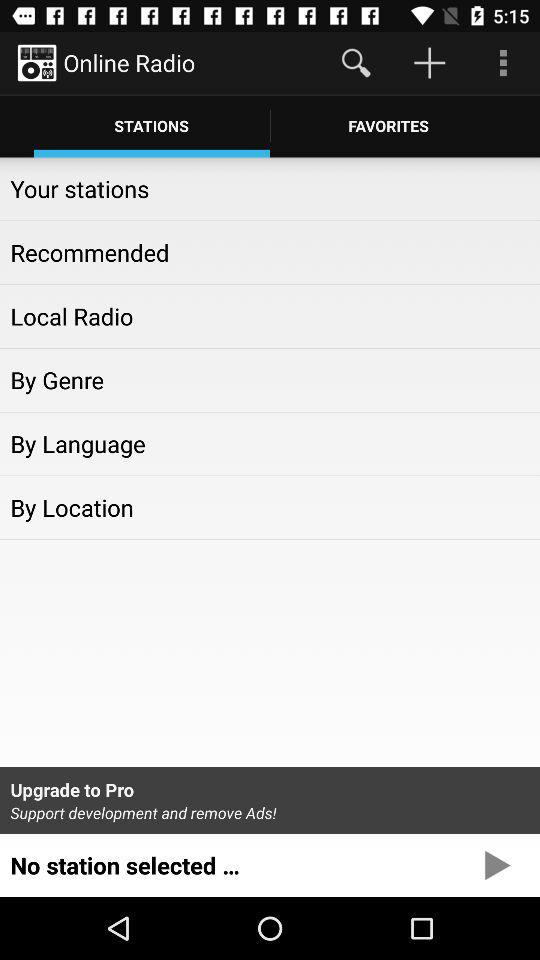Which tab am I on? You are on the "STATIONS" tab. 